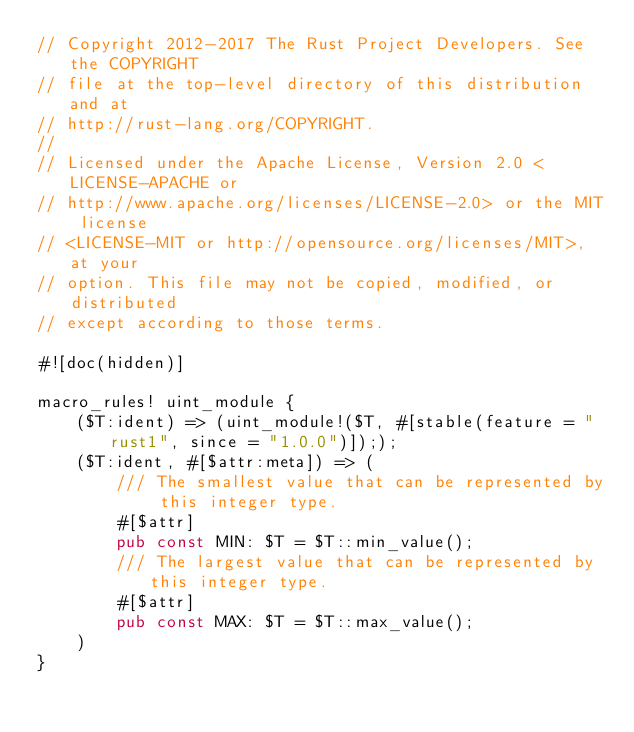Convert code to text. <code><loc_0><loc_0><loc_500><loc_500><_Rust_>// Copyright 2012-2017 The Rust Project Developers. See the COPYRIGHT
// file at the top-level directory of this distribution and at
// http://rust-lang.org/COPYRIGHT.
//
// Licensed under the Apache License, Version 2.0 <LICENSE-APACHE or
// http://www.apache.org/licenses/LICENSE-2.0> or the MIT license
// <LICENSE-MIT or http://opensource.org/licenses/MIT>, at your
// option. This file may not be copied, modified, or distributed
// except according to those terms.

#![doc(hidden)]

macro_rules! uint_module {
    ($T:ident) => (uint_module!($T, #[stable(feature = "rust1", since = "1.0.0")]););
    ($T:ident, #[$attr:meta]) => (
        /// The smallest value that can be represented by this integer type.
        #[$attr]
        pub const MIN: $T = $T::min_value();
        /// The largest value that can be represented by this integer type.
        #[$attr]
        pub const MAX: $T = $T::max_value();
    )
}
</code> 